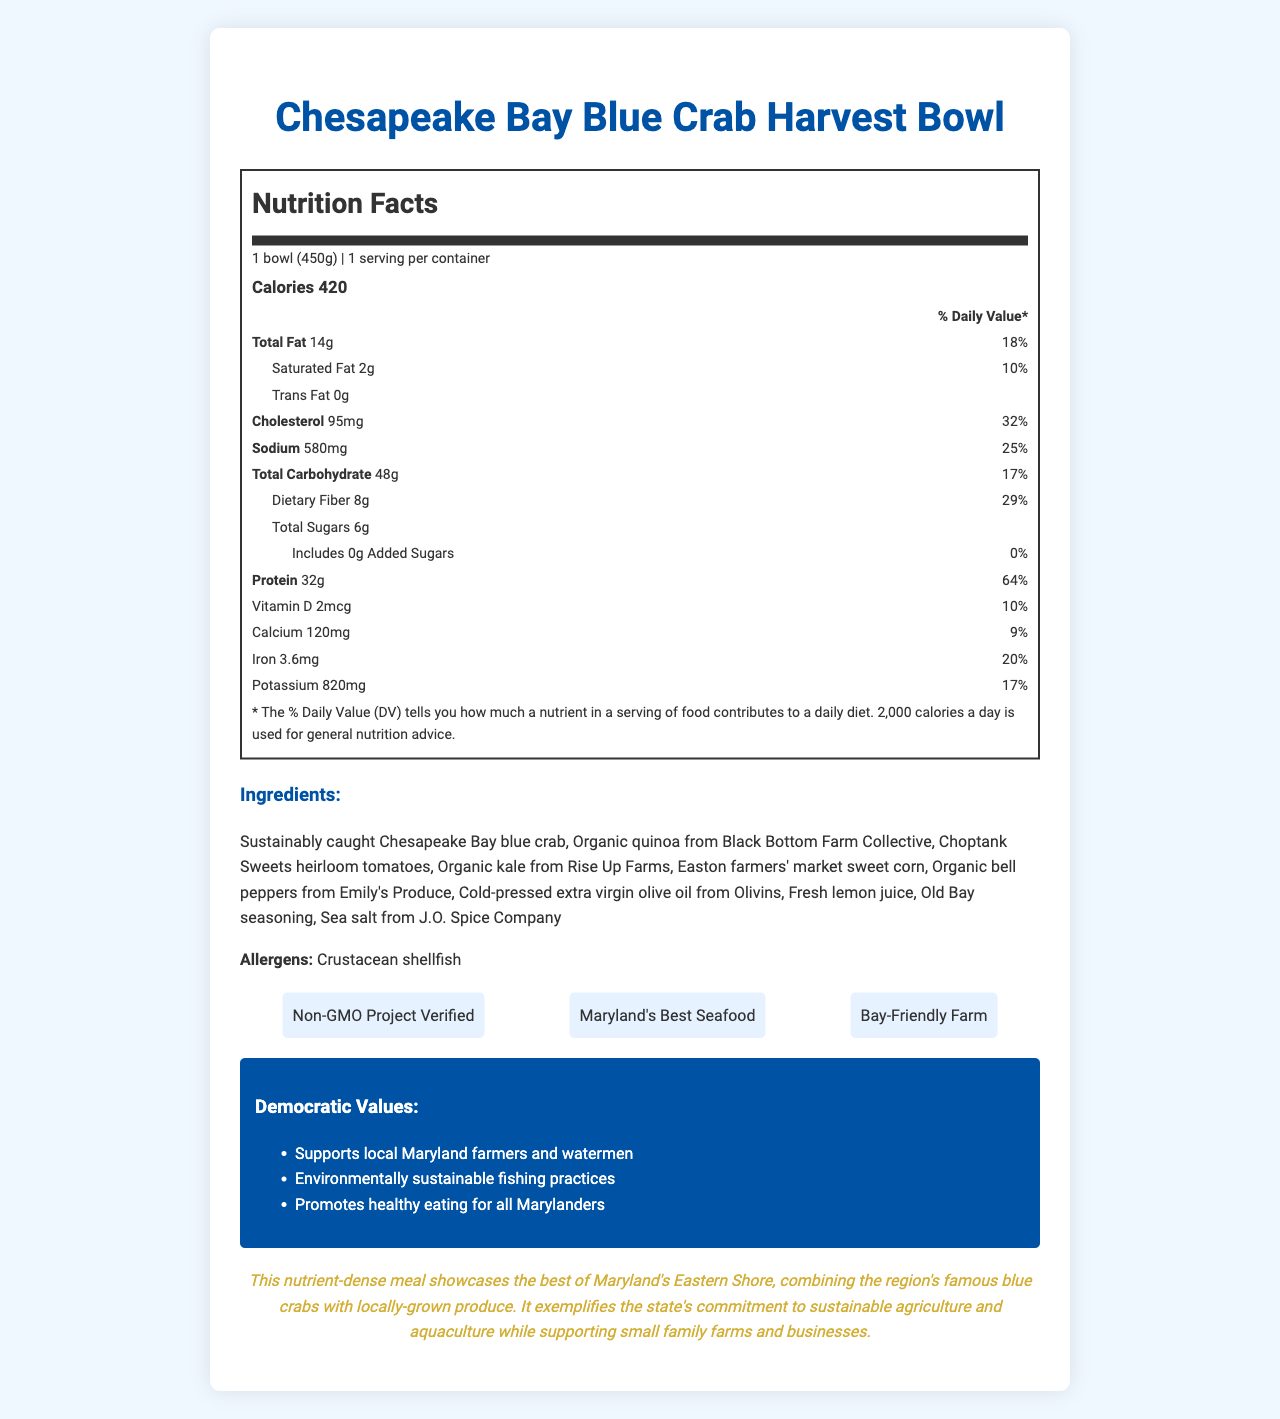what is the serving size of the Chesapeake Bay Blue Crab Harvest Bowl? The serving size is listed right at the beginning of the nutrition facts section.
Answer: 1 bowl (450g) how many calories are in one serving of the Harvest Bowl? The calorie content is specified below the serving size details in bold.
Answer: 420 what is the percentage of Daily Value for total fat? The Daily Value percentage for total fat is listed next to the total fat amount.
Answer: 18% how much dietary fiber does the Harvest Bowl contain? The dietary fiber amount is listed under the total carbohydrate section.
Answer: 8g how many grams of protein are in the Harvest Bowl? The protein amount is listed in the nutrition facts section in bold.
Answer: 32g how many mg of cholesterol are in one serving of this product? The cholesterol amount is listed in the nutrition facts section.
Answer: 95mg does the Harvest Bowl contain any trans fat? The trans fat amount is listed as 0g in the nutrition facts section.
Answer: No which certification does this product have? A. USDA Organic B. Fair Trade C. Non-GMO Project Verified D. Gluten-Free The certification labels listed under the document include "Non-GMO Project Verified."
Answer: C. Non-GMO Project Verified what allergens are present in this meal? A. Dairy B. Gluten C. Crustacean shellfish D. Nuts The allergens section lists "Crustacean shellfish" as present in the meal.
Answer: C. Crustacean shellfish is there any added sugar in the Harvest Bowl? The added sugar amount is listed as 0g in the nutrition facts.
Answer: No describe the main idea of this document. The document includes detailed nutrition facts, ingredients list, allergens, certifications, and statements about the product’s democratic values and support for Maryland's local produce.
Answer: This document provides the Nutrition Facts Label for the Chesapeake Bay Blue Crab Harvest Bowl, highlighting its nutritional content, ingredients sourced from Maryland farms, certifications, and alignment with Democratic values promoting local farming and sustainability. what is the main source of protein in this product? The document lists the ingredients, but it does not specify which ingredient is the main source of protein.
Answer: Not enough information 